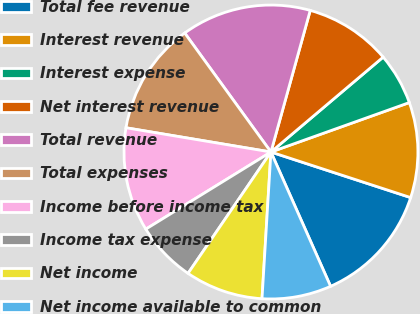Convert chart. <chart><loc_0><loc_0><loc_500><loc_500><pie_chart><fcel>Total fee revenue<fcel>Interest revenue<fcel>Interest expense<fcel>Net interest revenue<fcel>Total revenue<fcel>Total expenses<fcel>Income before income tax<fcel>Income tax expense<fcel>Net income<fcel>Net income available to common<nl><fcel>13.33%<fcel>10.48%<fcel>5.71%<fcel>9.52%<fcel>14.29%<fcel>12.38%<fcel>11.43%<fcel>6.67%<fcel>8.57%<fcel>7.62%<nl></chart> 